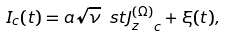Convert formula to latex. <formula><loc_0><loc_0><loc_500><loc_500>I _ { c } ( t ) = a \sqrt { \nu } \ s t { J _ { z } ^ { ( \Omega ) } } _ { c } + \xi ( t ) ,</formula> 